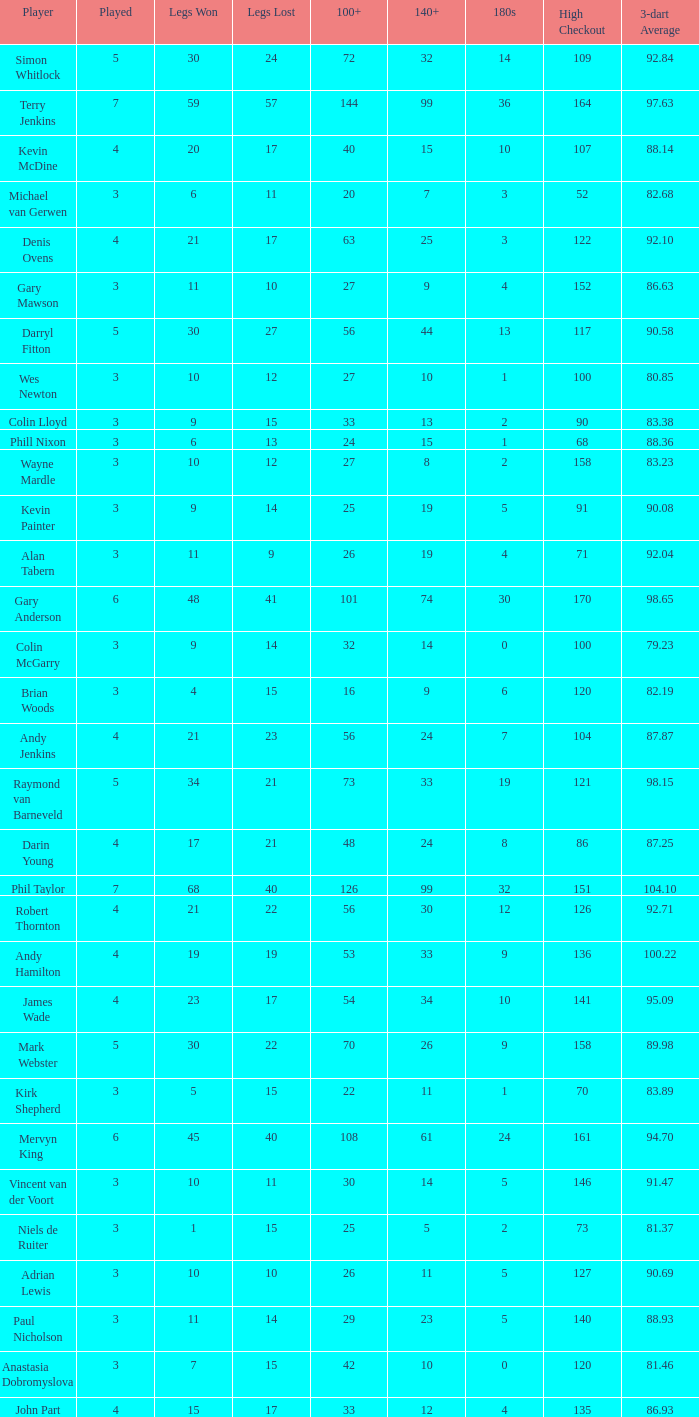What is the total number of 3-dart average when legs lost is larger than 41, and played is larger than 7? 0.0. 